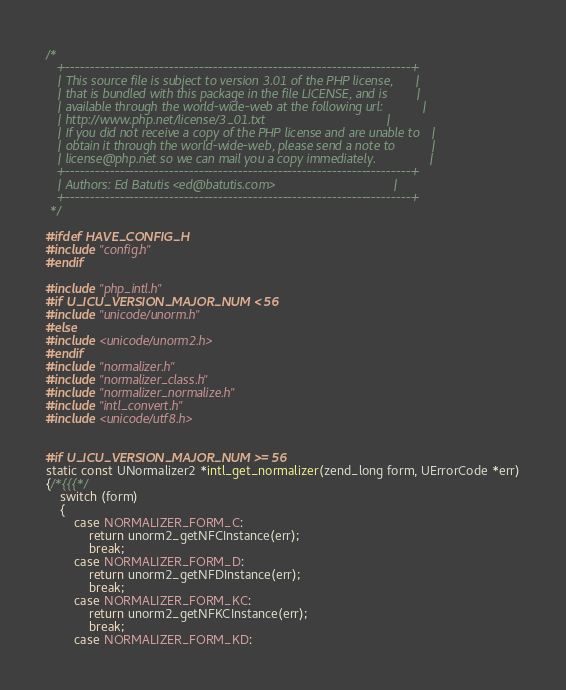<code> <loc_0><loc_0><loc_500><loc_500><_C_>/*
   +----------------------------------------------------------------------+
   | This source file is subject to version 3.01 of the PHP license,	  |
   | that is bundled with this package in the file LICENSE, and is		  |
   | available through the world-wide-web at the following url:			  |
   | http://www.php.net/license/3_01.txt								  |
   | If you did not receive a copy of the PHP license and are unable to   |
   | obtain it through the world-wide-web, please send a note to		  |
   | license@php.net so we can mail you a copy immediately.				  |
   +----------------------------------------------------------------------+
   | Authors: Ed Batutis <ed@batutis.com>								  |
   +----------------------------------------------------------------------+
 */

#ifdef HAVE_CONFIG_H
#include "config.h"
#endif

#include "php_intl.h"
#if U_ICU_VERSION_MAJOR_NUM < 56
#include "unicode/unorm.h"
#else
#include <unicode/unorm2.h>
#endif
#include "normalizer.h"
#include "normalizer_class.h"
#include "normalizer_normalize.h"
#include "intl_convert.h"
#include <unicode/utf8.h>


#if U_ICU_VERSION_MAJOR_NUM >= 56
static const UNormalizer2 *intl_get_normalizer(zend_long form, UErrorCode *err)
{/*{{{*/
	switch (form)
	{
		case NORMALIZER_FORM_C:
			return unorm2_getNFCInstance(err);
			break;
		case NORMALIZER_FORM_D:
			return unorm2_getNFDInstance(err);
			break;
		case NORMALIZER_FORM_KC:
			return unorm2_getNFKCInstance(err);
			break;
		case NORMALIZER_FORM_KD:</code> 